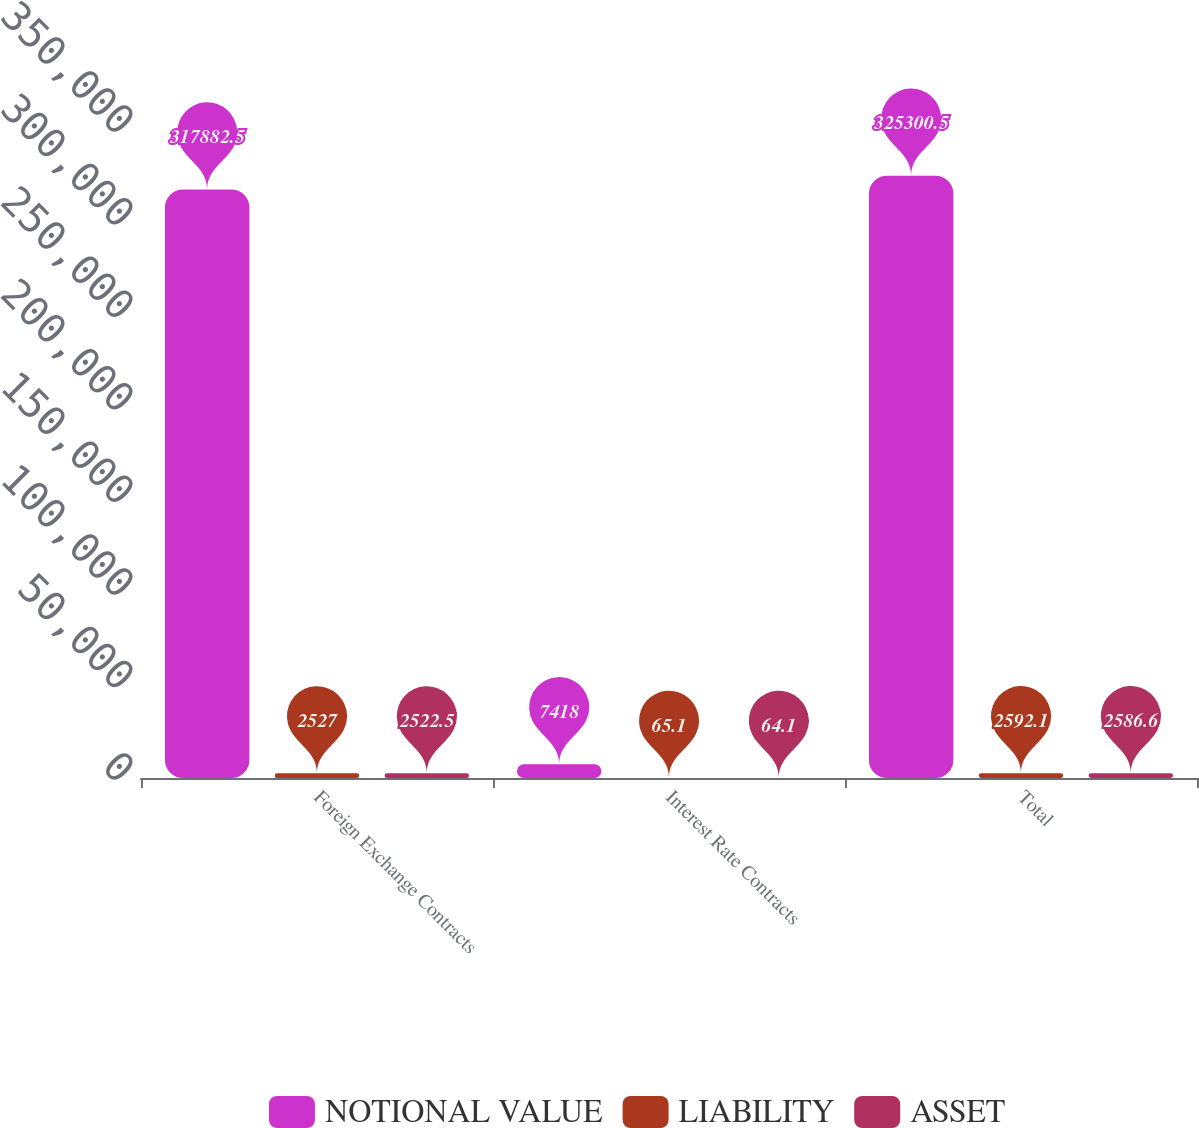Convert chart. <chart><loc_0><loc_0><loc_500><loc_500><stacked_bar_chart><ecel><fcel>Foreign Exchange Contracts<fcel>Interest Rate Contracts<fcel>Total<nl><fcel>NOTIONAL VALUE<fcel>317882<fcel>7418<fcel>325300<nl><fcel>LIABILITY<fcel>2527<fcel>65.1<fcel>2592.1<nl><fcel>ASSET<fcel>2522.5<fcel>64.1<fcel>2586.6<nl></chart> 